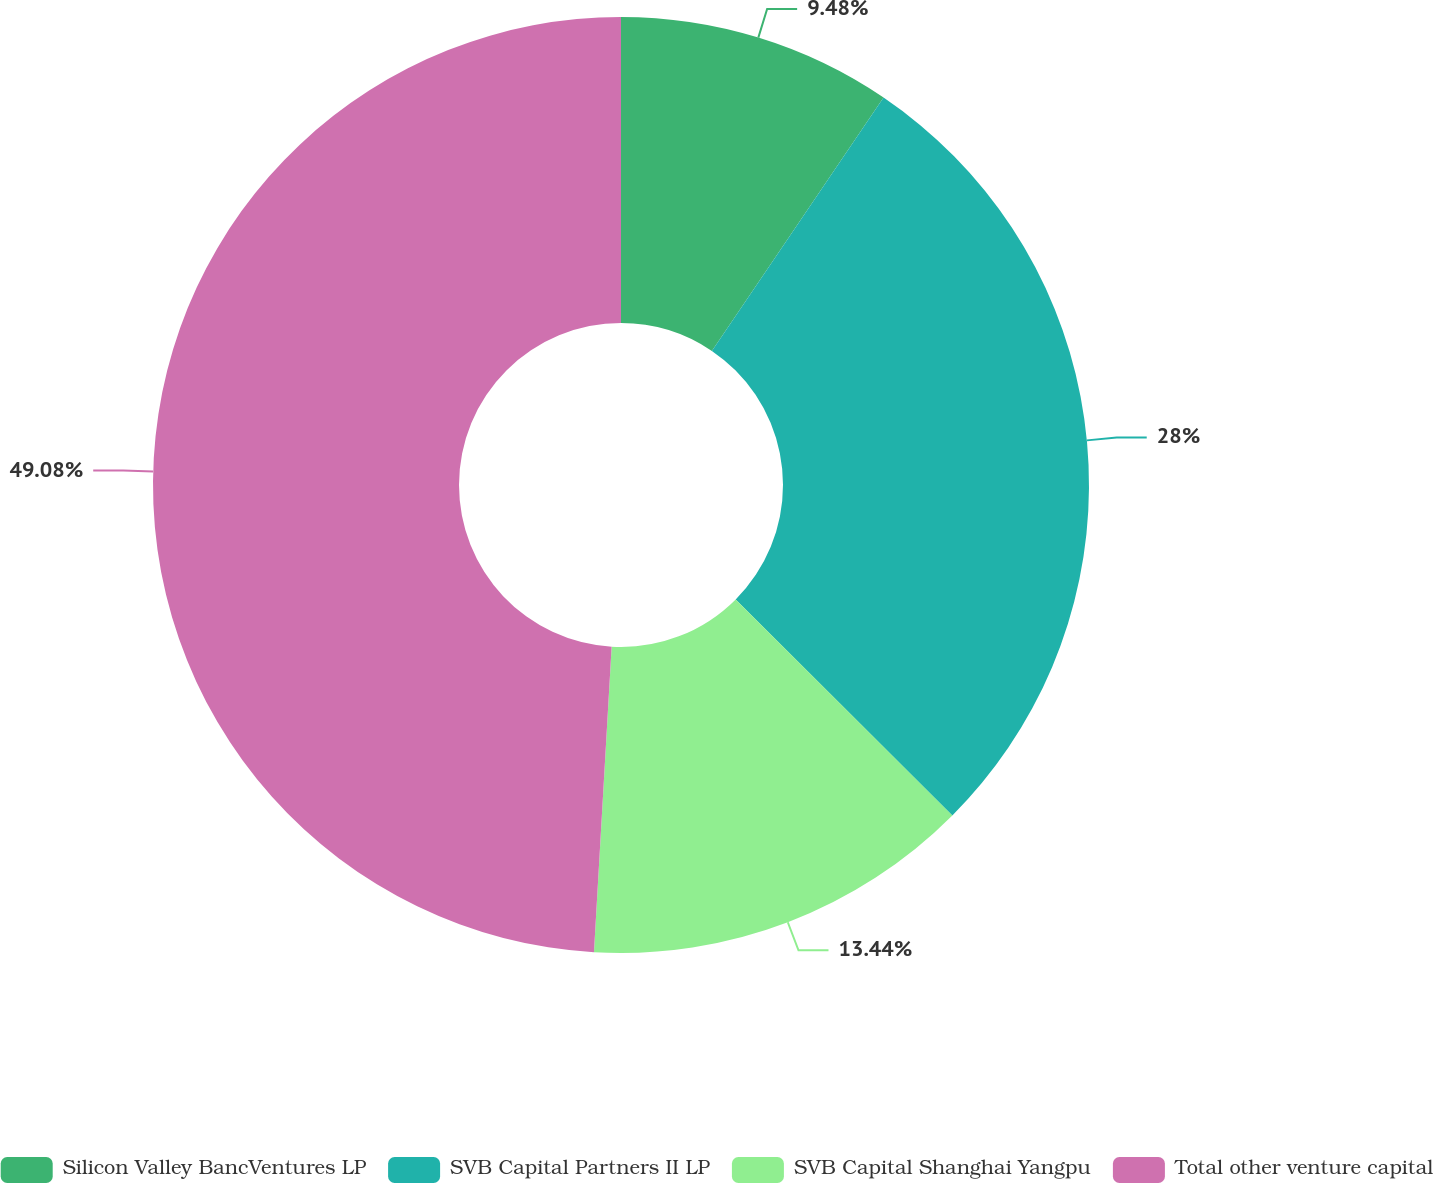Convert chart. <chart><loc_0><loc_0><loc_500><loc_500><pie_chart><fcel>Silicon Valley BancVentures LP<fcel>SVB Capital Partners II LP<fcel>SVB Capital Shanghai Yangpu<fcel>Total other venture capital<nl><fcel>9.48%<fcel>28.0%<fcel>13.44%<fcel>49.08%<nl></chart> 